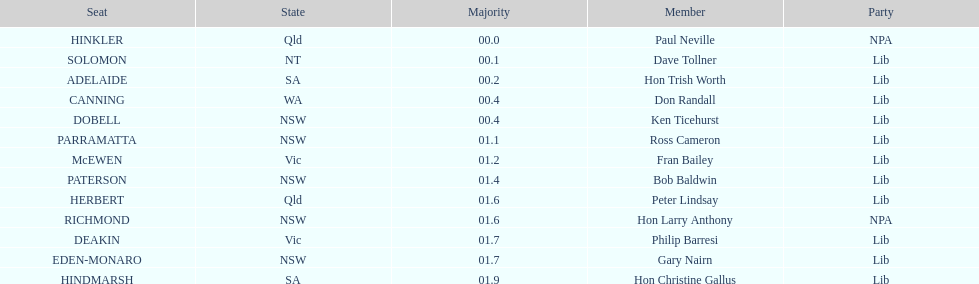What's the overall count of members? 13. 